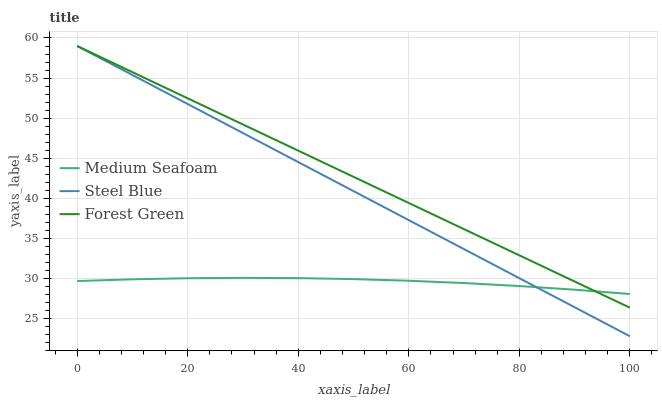Does Medium Seafoam have the minimum area under the curve?
Answer yes or no. Yes. Does Forest Green have the maximum area under the curve?
Answer yes or no. Yes. Does Steel Blue have the minimum area under the curve?
Answer yes or no. No. Does Steel Blue have the maximum area under the curve?
Answer yes or no. No. Is Steel Blue the smoothest?
Answer yes or no. Yes. Is Medium Seafoam the roughest?
Answer yes or no. Yes. Is Medium Seafoam the smoothest?
Answer yes or no. No. Is Steel Blue the roughest?
Answer yes or no. No. Does Steel Blue have the lowest value?
Answer yes or no. Yes. Does Medium Seafoam have the lowest value?
Answer yes or no. No. Does Steel Blue have the highest value?
Answer yes or no. Yes. Does Medium Seafoam have the highest value?
Answer yes or no. No. Does Medium Seafoam intersect Steel Blue?
Answer yes or no. Yes. Is Medium Seafoam less than Steel Blue?
Answer yes or no. No. Is Medium Seafoam greater than Steel Blue?
Answer yes or no. No. 